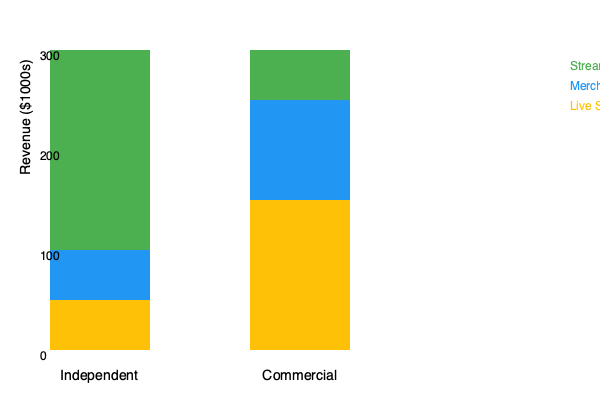Based on the stacked bar chart comparing revenue streams for independent and commercially successful artists, what is the ratio of merchandise revenue for commercial artists to independent artists? To find the ratio of merchandise revenue for commercial artists to independent artists, we need to:

1. Identify the merchandise revenue for each type of artist:
   - Independent artists: The blue section of the left bar, which spans from $200,000 to $300,000, representing $100,000 in merchandise revenue.
   - Commercial artists: The blue section of the right bar, which spans from $100,000 to $350,000, representing $250,000 in merchandise revenue.

2. Set up the ratio:
   Commercial merchandise revenue : Independent merchandise revenue
   $250,000 : $100,000

3. Simplify the ratio:
   250 : 100
   
4. Reduce to lowest terms:
   5 : 2

Therefore, the ratio of merchandise revenue for commercial artists to independent artists is 5:2.
Answer: 5:2 